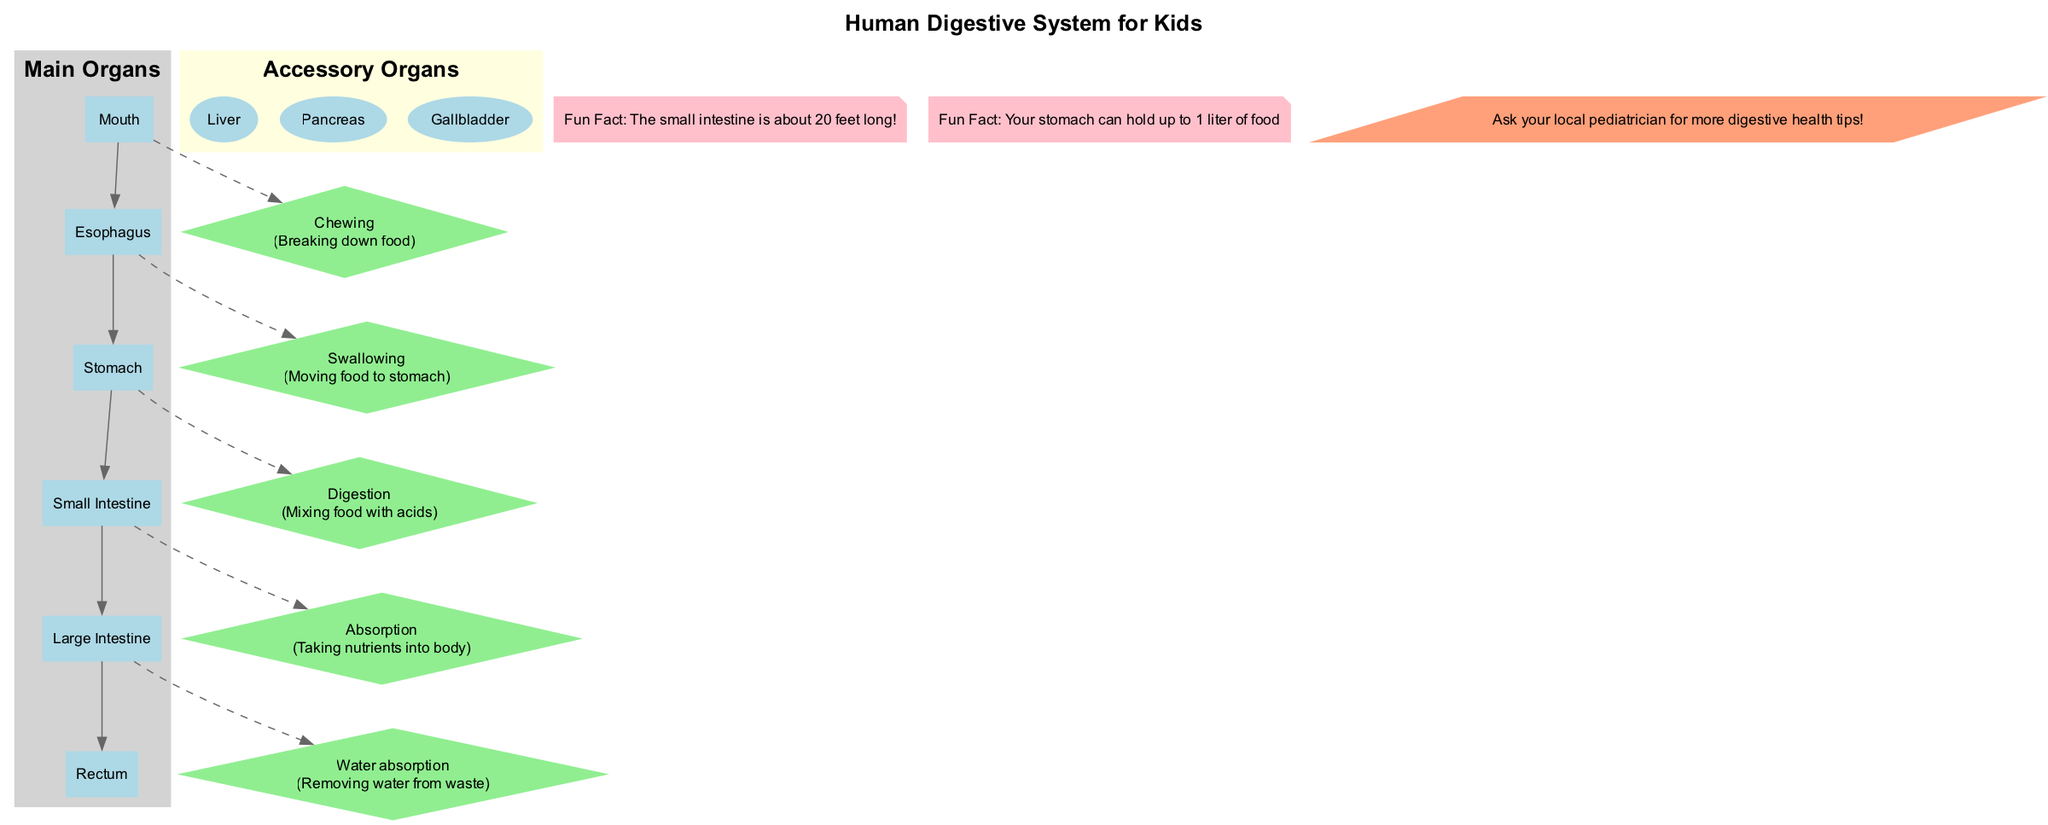What are the main organs highlighted in the diagram? The main organs are listed clearly in the "Main Organs" section of the diagram. They include: Mouth, Esophagus, Stomach, Small Intestine, Large Intestine, and Rectum.
Answer: Mouth, Esophagus, Stomach, Small Intestine, Large Intestine, Rectum How many accessory organs are shown? The "Accessory Organs" section indicates that there are three organs displayed, which are the Liver, Pancreas, and Gallbladder.
Answer: 3 What process occurs in the Stomach? The diagram notes that the process occurring in the Stomach is "Digestion", which is defined as mixing food with acids.
Answer: Digestion Which organ is responsible for water absorption? According to the diagram, the organ responsible for water absorption is the Large Intestine, which specifically removes water from waste.
Answer: Large Intestine What is the function of the Liver in the digestive system? While the diagram lists the Liver as an accessory organ, it doesn't specify its function directly. However, typically, the Liver plays a crucial role in processing nutrients. A viewer would need external knowledge about its function.
Answer: [Requires external knowledge] What process comes after swallowing food? Based on the flow of processes shown in the diagram, "Digestion" follows the "Swallowing" process, which occurs in the Stomach.
Answer: Digestion Which fun fact mentions the length of the small intestine? The fun fact presented in the diagram states: "The small intestine is about 20 feet long!" highlighting its impressive length.
Answer: 20 feet long What shape is used to represent processes in the diagram? The diagram uses diamonds to represent processes, differentiating them visually from the organs.
Answer: Diamond Where can I find tips for digestive health? The diagram suggests consulting with a local pediatrician for more digestive health tips, which is indicated in the local connection section.
Answer: Local pediatrician 